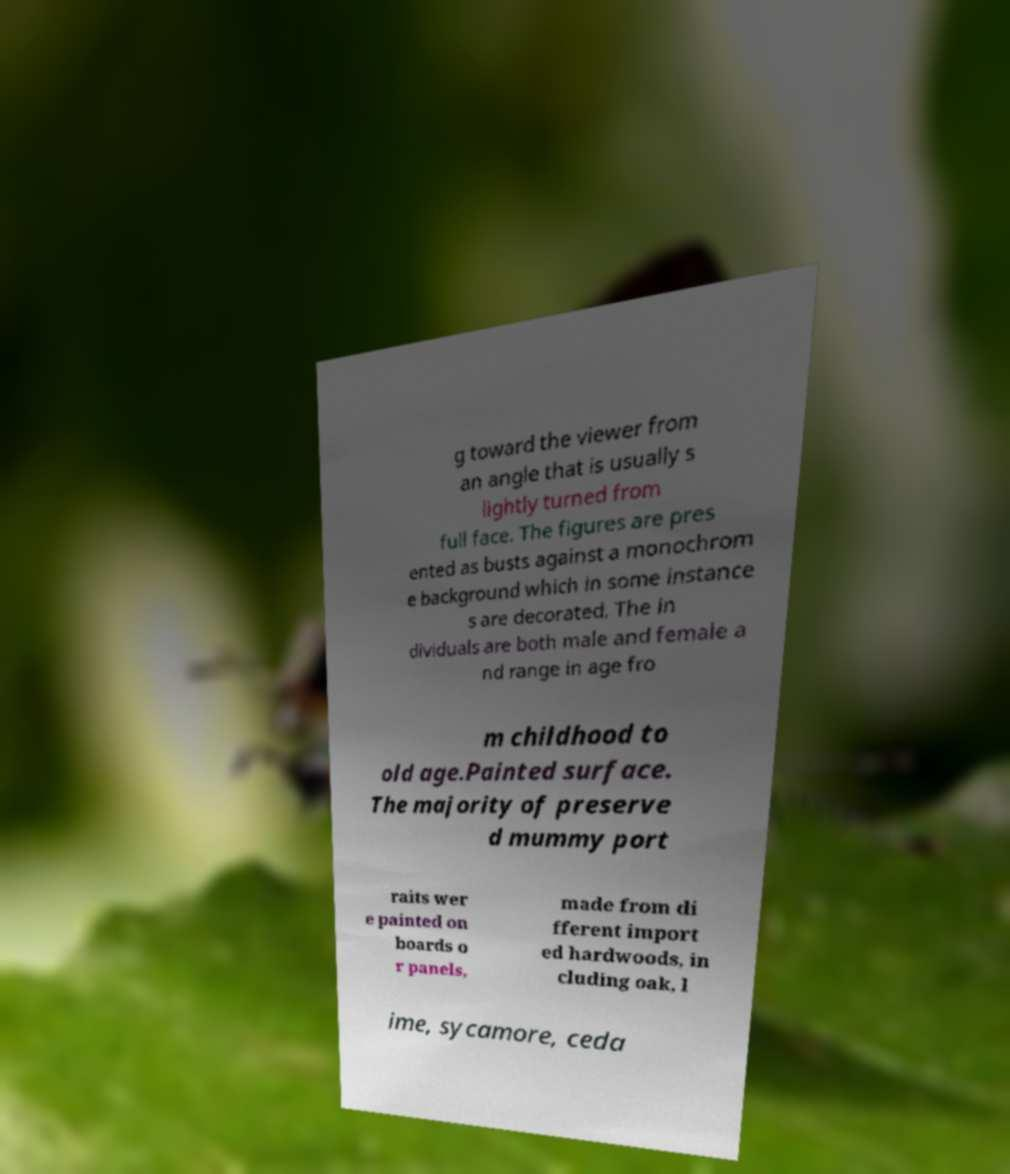Can you accurately transcribe the text from the provided image for me? g toward the viewer from an angle that is usually s lightly turned from full face. The figures are pres ented as busts against a monochrom e background which in some instance s are decorated. The in dividuals are both male and female a nd range in age fro m childhood to old age.Painted surface. The majority of preserve d mummy port raits wer e painted on boards o r panels, made from di fferent import ed hardwoods, in cluding oak, l ime, sycamore, ceda 